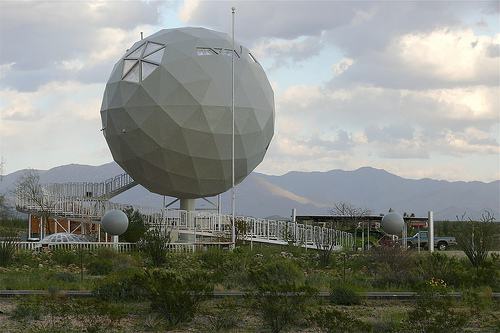<image>
Is there a pole in front of the ball? Yes. The pole is positioned in front of the ball, appearing closer to the camera viewpoint. 